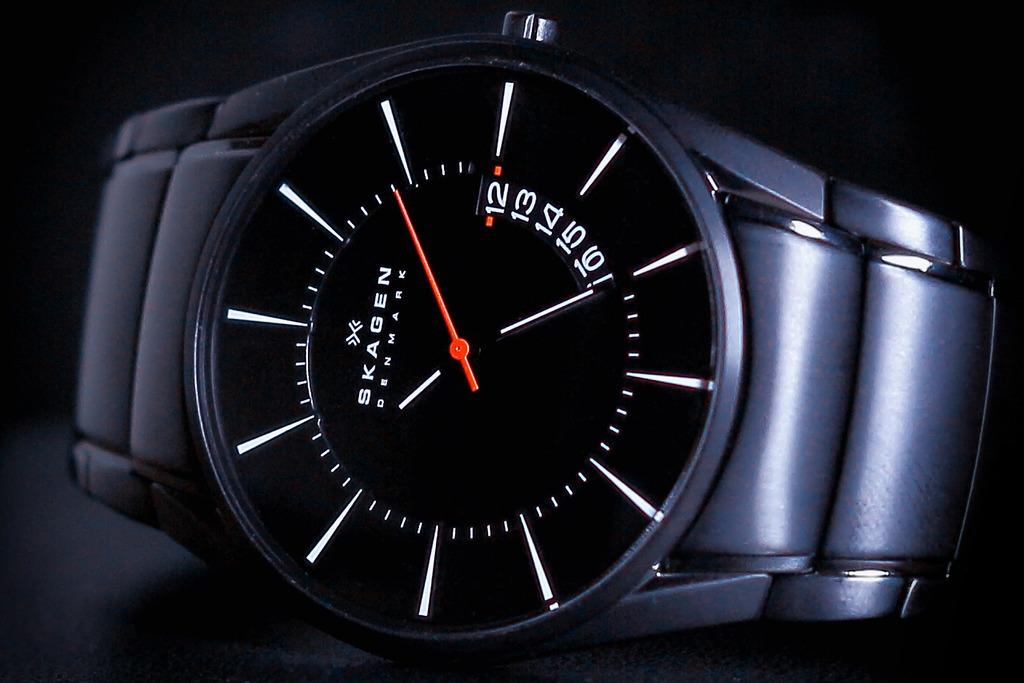<image>
Present a compact description of the photo's key features. Black watch with a face that has the word SKAGEN on it. 